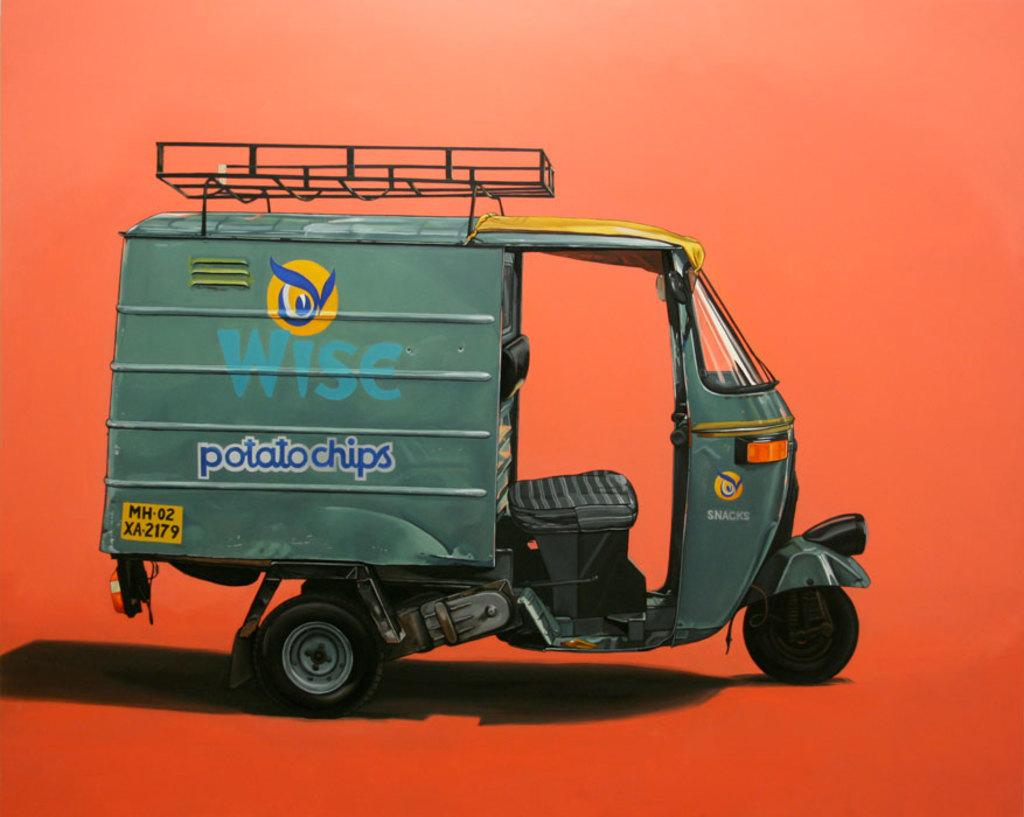What is the main subject of the image? There is an auto in the image. Is there a volcano erupting in the background of the image? There is no mention of a volcano or any background in the provided fact, so it cannot be determined from the image. 